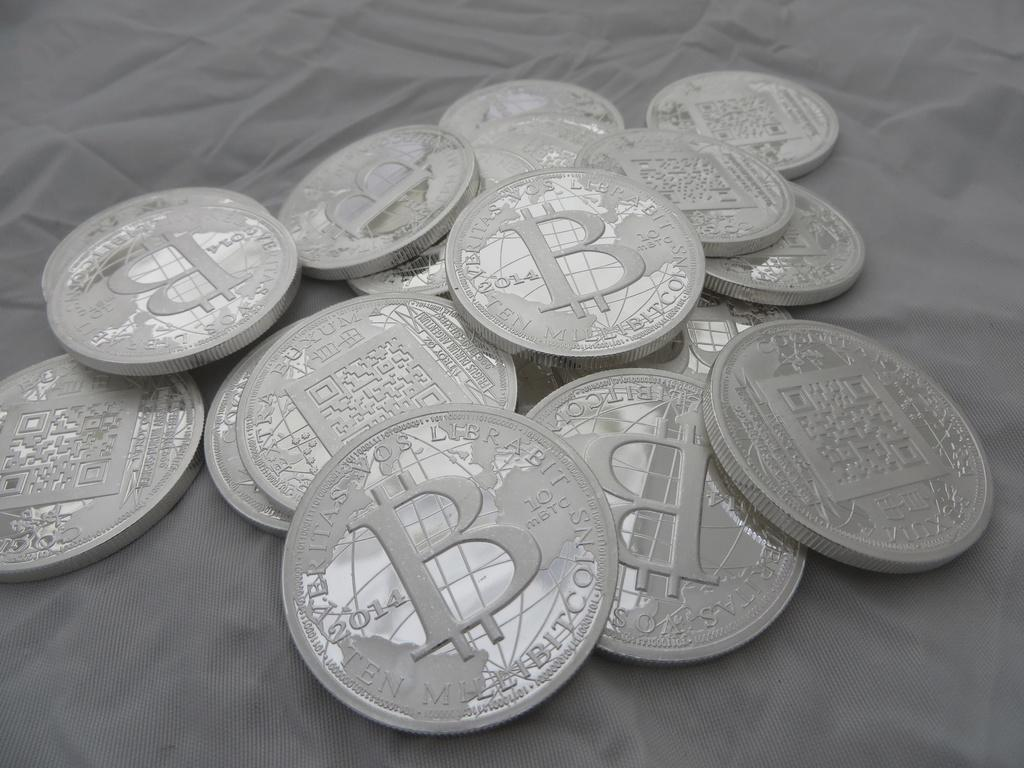<image>
Give a short and clear explanation of the subsequent image. silver coins in a pile with the letter B in the middle of all of them 